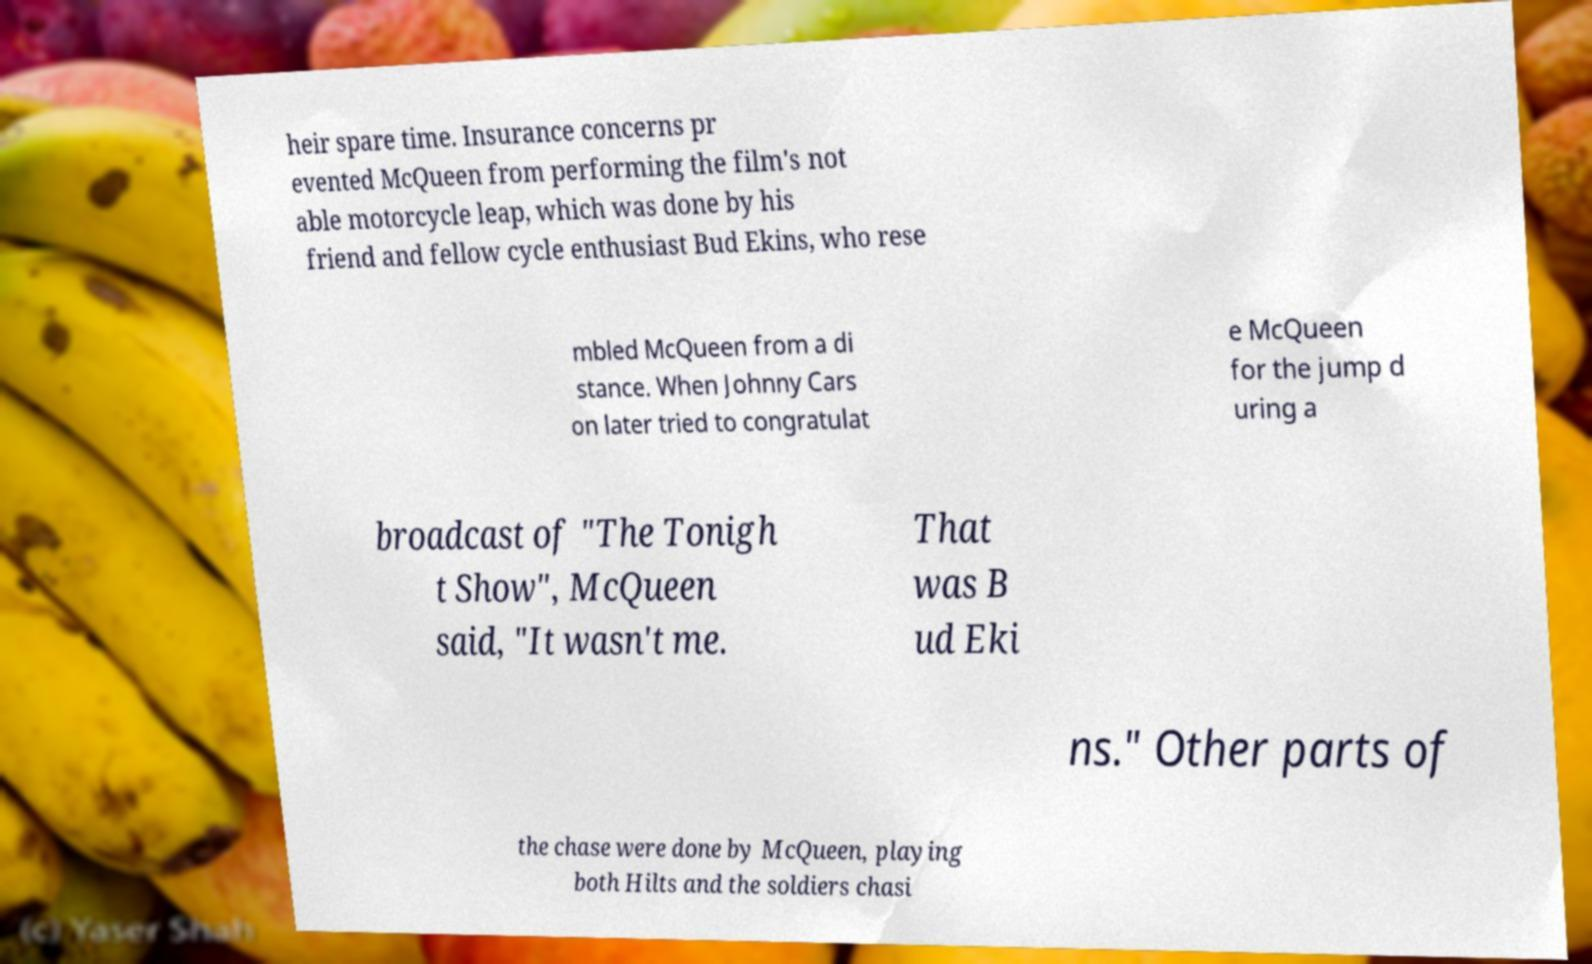Can you accurately transcribe the text from the provided image for me? heir spare time. Insurance concerns pr evented McQueen from performing the film's not able motorcycle leap, which was done by his friend and fellow cycle enthusiast Bud Ekins, who rese mbled McQueen from a di stance. When Johnny Cars on later tried to congratulat e McQueen for the jump d uring a broadcast of "The Tonigh t Show", McQueen said, "It wasn't me. That was B ud Eki ns." Other parts of the chase were done by McQueen, playing both Hilts and the soldiers chasi 